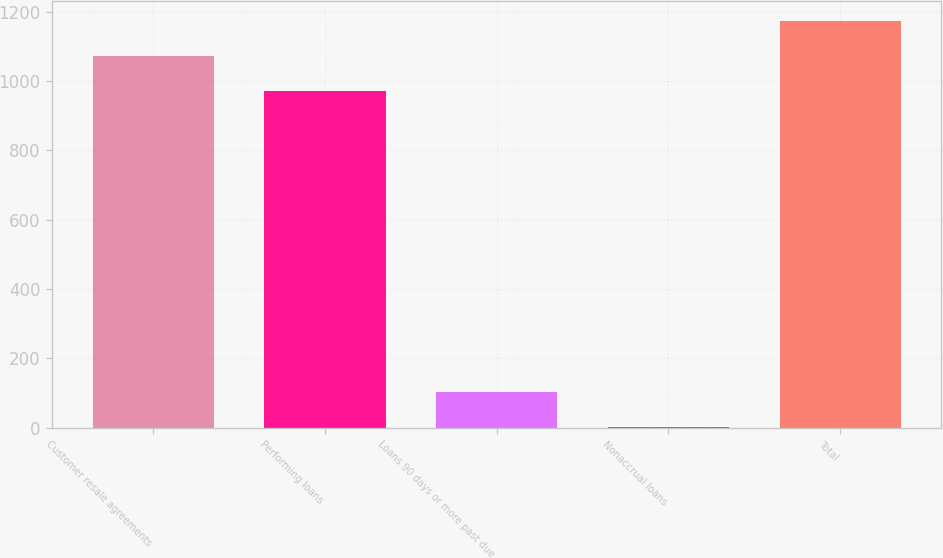<chart> <loc_0><loc_0><loc_500><loc_500><bar_chart><fcel>Customer resale agreements<fcel>Performing loans<fcel>Loans 90 days or more past due<fcel>Nonaccrual loans<fcel>Total<nl><fcel>1072.1<fcel>971<fcel>102.1<fcel>1<fcel>1173.2<nl></chart> 